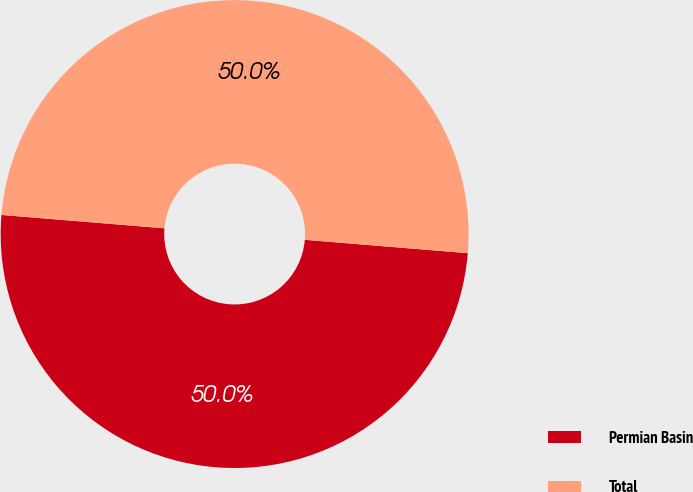Convert chart to OTSL. <chart><loc_0><loc_0><loc_500><loc_500><pie_chart><fcel>Permian Basin<fcel>Total<nl><fcel>50.0%<fcel>50.0%<nl></chart> 